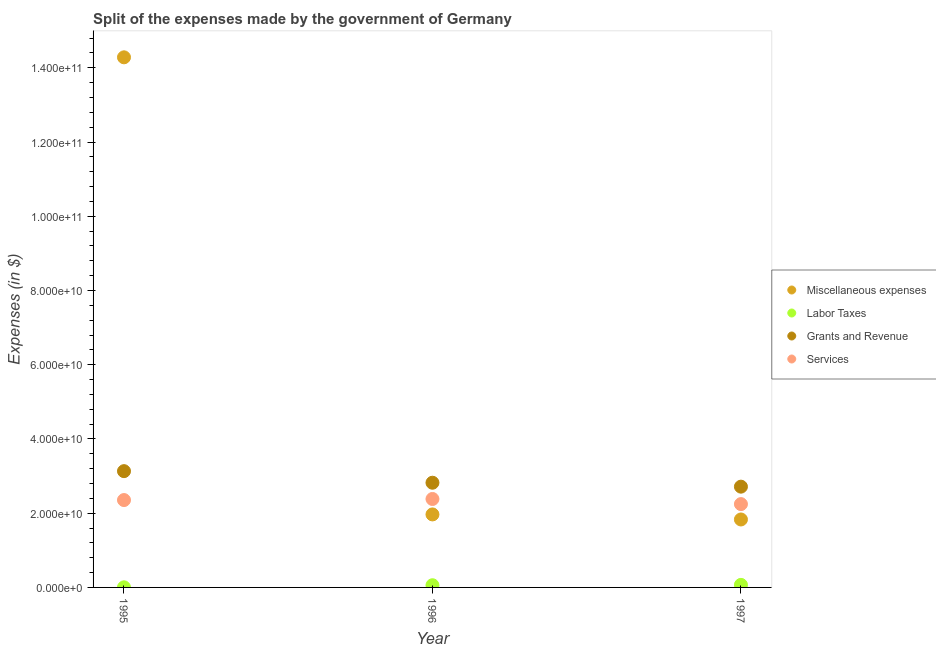What is the amount spent on miscellaneous expenses in 1997?
Offer a terse response. 1.83e+1. Across all years, what is the maximum amount spent on labor taxes?
Provide a succinct answer. 6.90e+08. Across all years, what is the minimum amount spent on labor taxes?
Your response must be concise. 3.00e+07. What is the total amount spent on grants and revenue in the graph?
Your answer should be very brief. 8.67e+1. What is the difference between the amount spent on miscellaneous expenses in 1996 and that in 1997?
Give a very brief answer. 1.36e+09. What is the difference between the amount spent on services in 1996 and the amount spent on grants and revenue in 1995?
Your answer should be compact. -7.50e+09. What is the average amount spent on labor taxes per year?
Ensure brevity in your answer.  4.37e+08. In the year 1997, what is the difference between the amount spent on services and amount spent on labor taxes?
Give a very brief answer. 2.18e+1. What is the ratio of the amount spent on grants and revenue in 1996 to that in 1997?
Provide a short and direct response. 1.04. Is the amount spent on grants and revenue in 1995 less than that in 1996?
Your answer should be very brief. No. What is the difference between the highest and the second highest amount spent on miscellaneous expenses?
Give a very brief answer. 1.23e+11. What is the difference between the highest and the lowest amount spent on miscellaneous expenses?
Make the answer very short. 1.25e+11. In how many years, is the amount spent on grants and revenue greater than the average amount spent on grants and revenue taken over all years?
Provide a succinct answer. 1. Is it the case that in every year, the sum of the amount spent on miscellaneous expenses and amount spent on labor taxes is greater than the amount spent on grants and revenue?
Provide a short and direct response. No. Does the amount spent on miscellaneous expenses monotonically increase over the years?
Your response must be concise. No. How many years are there in the graph?
Your response must be concise. 3. What is the difference between two consecutive major ticks on the Y-axis?
Provide a short and direct response. 2.00e+1. Are the values on the major ticks of Y-axis written in scientific E-notation?
Ensure brevity in your answer.  Yes. Where does the legend appear in the graph?
Provide a short and direct response. Center right. How are the legend labels stacked?
Keep it short and to the point. Vertical. What is the title of the graph?
Your answer should be very brief. Split of the expenses made by the government of Germany. What is the label or title of the X-axis?
Give a very brief answer. Year. What is the label or title of the Y-axis?
Offer a very short reply. Expenses (in $). What is the Expenses (in $) in Miscellaneous expenses in 1995?
Offer a very short reply. 1.43e+11. What is the Expenses (in $) of Labor Taxes in 1995?
Keep it short and to the point. 3.00e+07. What is the Expenses (in $) in Grants and Revenue in 1995?
Provide a succinct answer. 3.13e+1. What is the Expenses (in $) in Services in 1995?
Give a very brief answer. 2.35e+1. What is the Expenses (in $) in Miscellaneous expenses in 1996?
Provide a succinct answer. 1.97e+1. What is the Expenses (in $) of Labor Taxes in 1996?
Your answer should be compact. 5.90e+08. What is the Expenses (in $) of Grants and Revenue in 1996?
Ensure brevity in your answer.  2.82e+1. What is the Expenses (in $) in Services in 1996?
Provide a short and direct response. 2.38e+1. What is the Expenses (in $) of Miscellaneous expenses in 1997?
Give a very brief answer. 1.83e+1. What is the Expenses (in $) of Labor Taxes in 1997?
Provide a succinct answer. 6.90e+08. What is the Expenses (in $) in Grants and Revenue in 1997?
Your response must be concise. 2.72e+1. What is the Expenses (in $) of Services in 1997?
Offer a very short reply. 2.24e+1. Across all years, what is the maximum Expenses (in $) of Miscellaneous expenses?
Provide a succinct answer. 1.43e+11. Across all years, what is the maximum Expenses (in $) in Labor Taxes?
Offer a very short reply. 6.90e+08. Across all years, what is the maximum Expenses (in $) in Grants and Revenue?
Provide a short and direct response. 3.13e+1. Across all years, what is the maximum Expenses (in $) of Services?
Your response must be concise. 2.38e+1. Across all years, what is the minimum Expenses (in $) of Miscellaneous expenses?
Provide a short and direct response. 1.83e+1. Across all years, what is the minimum Expenses (in $) in Labor Taxes?
Provide a succinct answer. 3.00e+07. Across all years, what is the minimum Expenses (in $) in Grants and Revenue?
Provide a short and direct response. 2.72e+1. Across all years, what is the minimum Expenses (in $) of Services?
Offer a very short reply. 2.24e+1. What is the total Expenses (in $) of Miscellaneous expenses in the graph?
Offer a terse response. 1.81e+11. What is the total Expenses (in $) in Labor Taxes in the graph?
Make the answer very short. 1.31e+09. What is the total Expenses (in $) of Grants and Revenue in the graph?
Provide a succinct answer. 8.67e+1. What is the total Expenses (in $) in Services in the graph?
Your answer should be compact. 6.98e+1. What is the difference between the Expenses (in $) in Miscellaneous expenses in 1995 and that in 1996?
Offer a very short reply. 1.23e+11. What is the difference between the Expenses (in $) in Labor Taxes in 1995 and that in 1996?
Give a very brief answer. -5.60e+08. What is the difference between the Expenses (in $) of Grants and Revenue in 1995 and that in 1996?
Your answer should be compact. 3.12e+09. What is the difference between the Expenses (in $) in Services in 1995 and that in 1996?
Give a very brief answer. -2.90e+08. What is the difference between the Expenses (in $) in Miscellaneous expenses in 1995 and that in 1997?
Provide a short and direct response. 1.25e+11. What is the difference between the Expenses (in $) in Labor Taxes in 1995 and that in 1997?
Your answer should be very brief. -6.60e+08. What is the difference between the Expenses (in $) in Grants and Revenue in 1995 and that in 1997?
Offer a very short reply. 4.18e+09. What is the difference between the Expenses (in $) in Services in 1995 and that in 1997?
Keep it short and to the point. 1.09e+09. What is the difference between the Expenses (in $) of Miscellaneous expenses in 1996 and that in 1997?
Make the answer very short. 1.36e+09. What is the difference between the Expenses (in $) in Labor Taxes in 1996 and that in 1997?
Offer a very short reply. -1.00e+08. What is the difference between the Expenses (in $) in Grants and Revenue in 1996 and that in 1997?
Your response must be concise. 1.06e+09. What is the difference between the Expenses (in $) in Services in 1996 and that in 1997?
Offer a very short reply. 1.38e+09. What is the difference between the Expenses (in $) in Miscellaneous expenses in 1995 and the Expenses (in $) in Labor Taxes in 1996?
Your answer should be compact. 1.42e+11. What is the difference between the Expenses (in $) in Miscellaneous expenses in 1995 and the Expenses (in $) in Grants and Revenue in 1996?
Offer a very short reply. 1.15e+11. What is the difference between the Expenses (in $) in Miscellaneous expenses in 1995 and the Expenses (in $) in Services in 1996?
Offer a terse response. 1.19e+11. What is the difference between the Expenses (in $) of Labor Taxes in 1995 and the Expenses (in $) of Grants and Revenue in 1996?
Your answer should be very brief. -2.82e+1. What is the difference between the Expenses (in $) in Labor Taxes in 1995 and the Expenses (in $) in Services in 1996?
Ensure brevity in your answer.  -2.38e+1. What is the difference between the Expenses (in $) of Grants and Revenue in 1995 and the Expenses (in $) of Services in 1996?
Ensure brevity in your answer.  7.50e+09. What is the difference between the Expenses (in $) in Miscellaneous expenses in 1995 and the Expenses (in $) in Labor Taxes in 1997?
Make the answer very short. 1.42e+11. What is the difference between the Expenses (in $) of Miscellaneous expenses in 1995 and the Expenses (in $) of Grants and Revenue in 1997?
Keep it short and to the point. 1.16e+11. What is the difference between the Expenses (in $) of Miscellaneous expenses in 1995 and the Expenses (in $) of Services in 1997?
Make the answer very short. 1.20e+11. What is the difference between the Expenses (in $) in Labor Taxes in 1995 and the Expenses (in $) in Grants and Revenue in 1997?
Your response must be concise. -2.71e+1. What is the difference between the Expenses (in $) in Labor Taxes in 1995 and the Expenses (in $) in Services in 1997?
Keep it short and to the point. -2.24e+1. What is the difference between the Expenses (in $) of Grants and Revenue in 1995 and the Expenses (in $) of Services in 1997?
Give a very brief answer. 8.88e+09. What is the difference between the Expenses (in $) in Miscellaneous expenses in 1996 and the Expenses (in $) in Labor Taxes in 1997?
Your response must be concise. 1.90e+1. What is the difference between the Expenses (in $) in Miscellaneous expenses in 1996 and the Expenses (in $) in Grants and Revenue in 1997?
Make the answer very short. -7.48e+09. What is the difference between the Expenses (in $) of Miscellaneous expenses in 1996 and the Expenses (in $) of Services in 1997?
Your answer should be compact. -2.78e+09. What is the difference between the Expenses (in $) in Labor Taxes in 1996 and the Expenses (in $) in Grants and Revenue in 1997?
Offer a very short reply. -2.66e+1. What is the difference between the Expenses (in $) in Labor Taxes in 1996 and the Expenses (in $) in Services in 1997?
Provide a succinct answer. -2.19e+1. What is the difference between the Expenses (in $) of Grants and Revenue in 1996 and the Expenses (in $) of Services in 1997?
Your answer should be compact. 5.76e+09. What is the average Expenses (in $) in Miscellaneous expenses per year?
Keep it short and to the point. 6.03e+1. What is the average Expenses (in $) of Labor Taxes per year?
Provide a short and direct response. 4.37e+08. What is the average Expenses (in $) of Grants and Revenue per year?
Provide a succinct answer. 2.89e+1. What is the average Expenses (in $) of Services per year?
Your response must be concise. 2.33e+1. In the year 1995, what is the difference between the Expenses (in $) of Miscellaneous expenses and Expenses (in $) of Labor Taxes?
Give a very brief answer. 1.43e+11. In the year 1995, what is the difference between the Expenses (in $) of Miscellaneous expenses and Expenses (in $) of Grants and Revenue?
Offer a terse response. 1.11e+11. In the year 1995, what is the difference between the Expenses (in $) in Miscellaneous expenses and Expenses (in $) in Services?
Offer a terse response. 1.19e+11. In the year 1995, what is the difference between the Expenses (in $) of Labor Taxes and Expenses (in $) of Grants and Revenue?
Offer a terse response. -3.13e+1. In the year 1995, what is the difference between the Expenses (in $) of Labor Taxes and Expenses (in $) of Services?
Offer a terse response. -2.35e+1. In the year 1995, what is the difference between the Expenses (in $) in Grants and Revenue and Expenses (in $) in Services?
Make the answer very short. 7.79e+09. In the year 1996, what is the difference between the Expenses (in $) of Miscellaneous expenses and Expenses (in $) of Labor Taxes?
Make the answer very short. 1.91e+1. In the year 1996, what is the difference between the Expenses (in $) of Miscellaneous expenses and Expenses (in $) of Grants and Revenue?
Give a very brief answer. -8.54e+09. In the year 1996, what is the difference between the Expenses (in $) in Miscellaneous expenses and Expenses (in $) in Services?
Give a very brief answer. -4.16e+09. In the year 1996, what is the difference between the Expenses (in $) of Labor Taxes and Expenses (in $) of Grants and Revenue?
Your answer should be compact. -2.76e+1. In the year 1996, what is the difference between the Expenses (in $) in Labor Taxes and Expenses (in $) in Services?
Ensure brevity in your answer.  -2.32e+1. In the year 1996, what is the difference between the Expenses (in $) of Grants and Revenue and Expenses (in $) of Services?
Ensure brevity in your answer.  4.38e+09. In the year 1997, what is the difference between the Expenses (in $) of Miscellaneous expenses and Expenses (in $) of Labor Taxes?
Offer a very short reply. 1.76e+1. In the year 1997, what is the difference between the Expenses (in $) in Miscellaneous expenses and Expenses (in $) in Grants and Revenue?
Keep it short and to the point. -8.84e+09. In the year 1997, what is the difference between the Expenses (in $) in Miscellaneous expenses and Expenses (in $) in Services?
Offer a very short reply. -4.14e+09. In the year 1997, what is the difference between the Expenses (in $) of Labor Taxes and Expenses (in $) of Grants and Revenue?
Offer a terse response. -2.65e+1. In the year 1997, what is the difference between the Expenses (in $) of Labor Taxes and Expenses (in $) of Services?
Your response must be concise. -2.18e+1. In the year 1997, what is the difference between the Expenses (in $) in Grants and Revenue and Expenses (in $) in Services?
Offer a very short reply. 4.70e+09. What is the ratio of the Expenses (in $) in Miscellaneous expenses in 1995 to that in 1996?
Ensure brevity in your answer.  7.26. What is the ratio of the Expenses (in $) in Labor Taxes in 1995 to that in 1996?
Your response must be concise. 0.05. What is the ratio of the Expenses (in $) of Grants and Revenue in 1995 to that in 1996?
Offer a very short reply. 1.11. What is the ratio of the Expenses (in $) of Miscellaneous expenses in 1995 to that in 1997?
Make the answer very short. 7.8. What is the ratio of the Expenses (in $) of Labor Taxes in 1995 to that in 1997?
Your response must be concise. 0.04. What is the ratio of the Expenses (in $) of Grants and Revenue in 1995 to that in 1997?
Provide a short and direct response. 1.15. What is the ratio of the Expenses (in $) in Services in 1995 to that in 1997?
Your answer should be compact. 1.05. What is the ratio of the Expenses (in $) of Miscellaneous expenses in 1996 to that in 1997?
Ensure brevity in your answer.  1.07. What is the ratio of the Expenses (in $) of Labor Taxes in 1996 to that in 1997?
Keep it short and to the point. 0.86. What is the ratio of the Expenses (in $) in Grants and Revenue in 1996 to that in 1997?
Offer a very short reply. 1.04. What is the ratio of the Expenses (in $) in Services in 1996 to that in 1997?
Your answer should be very brief. 1.06. What is the difference between the highest and the second highest Expenses (in $) in Miscellaneous expenses?
Your answer should be very brief. 1.23e+11. What is the difference between the highest and the second highest Expenses (in $) in Grants and Revenue?
Your response must be concise. 3.12e+09. What is the difference between the highest and the second highest Expenses (in $) of Services?
Make the answer very short. 2.90e+08. What is the difference between the highest and the lowest Expenses (in $) of Miscellaneous expenses?
Make the answer very short. 1.25e+11. What is the difference between the highest and the lowest Expenses (in $) of Labor Taxes?
Give a very brief answer. 6.60e+08. What is the difference between the highest and the lowest Expenses (in $) in Grants and Revenue?
Provide a succinct answer. 4.18e+09. What is the difference between the highest and the lowest Expenses (in $) in Services?
Your answer should be very brief. 1.38e+09. 